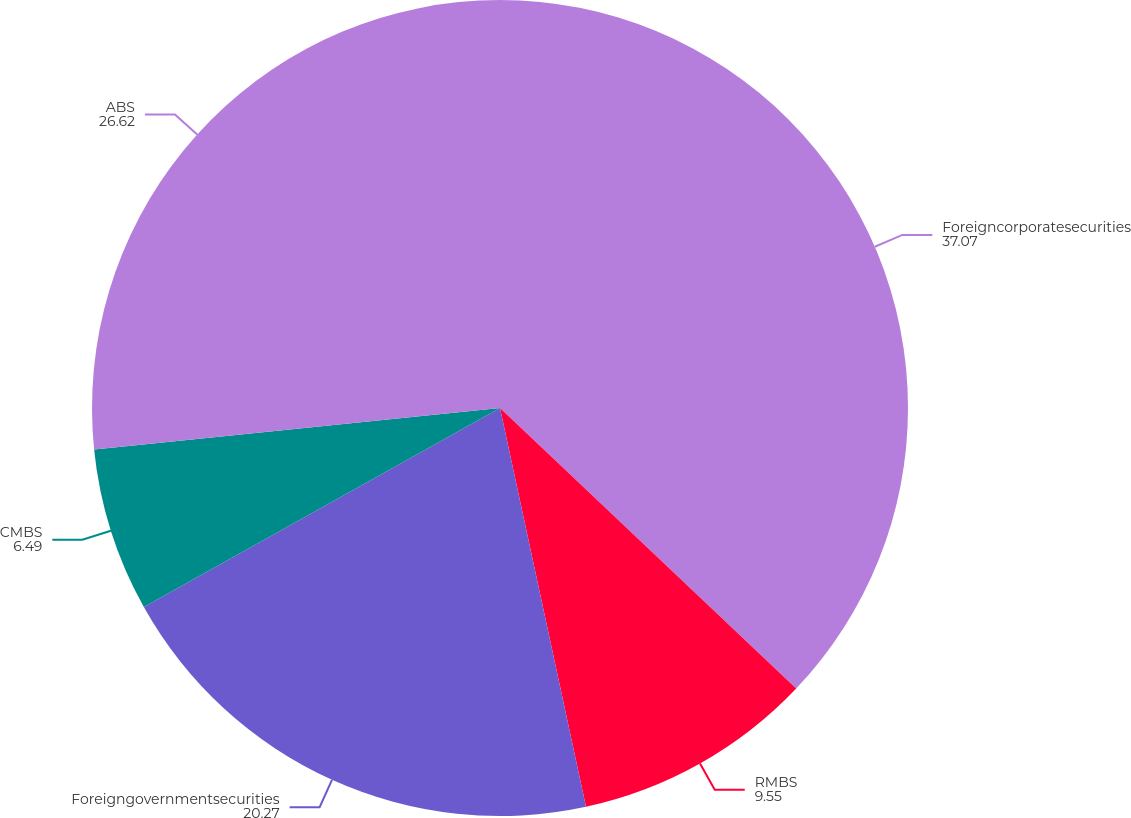Convert chart. <chart><loc_0><loc_0><loc_500><loc_500><pie_chart><fcel>Foreigncorporatesecurities<fcel>RMBS<fcel>Foreigngovernmentsecurities<fcel>CMBS<fcel>ABS<nl><fcel>37.07%<fcel>9.55%<fcel>20.27%<fcel>6.49%<fcel>26.62%<nl></chart> 